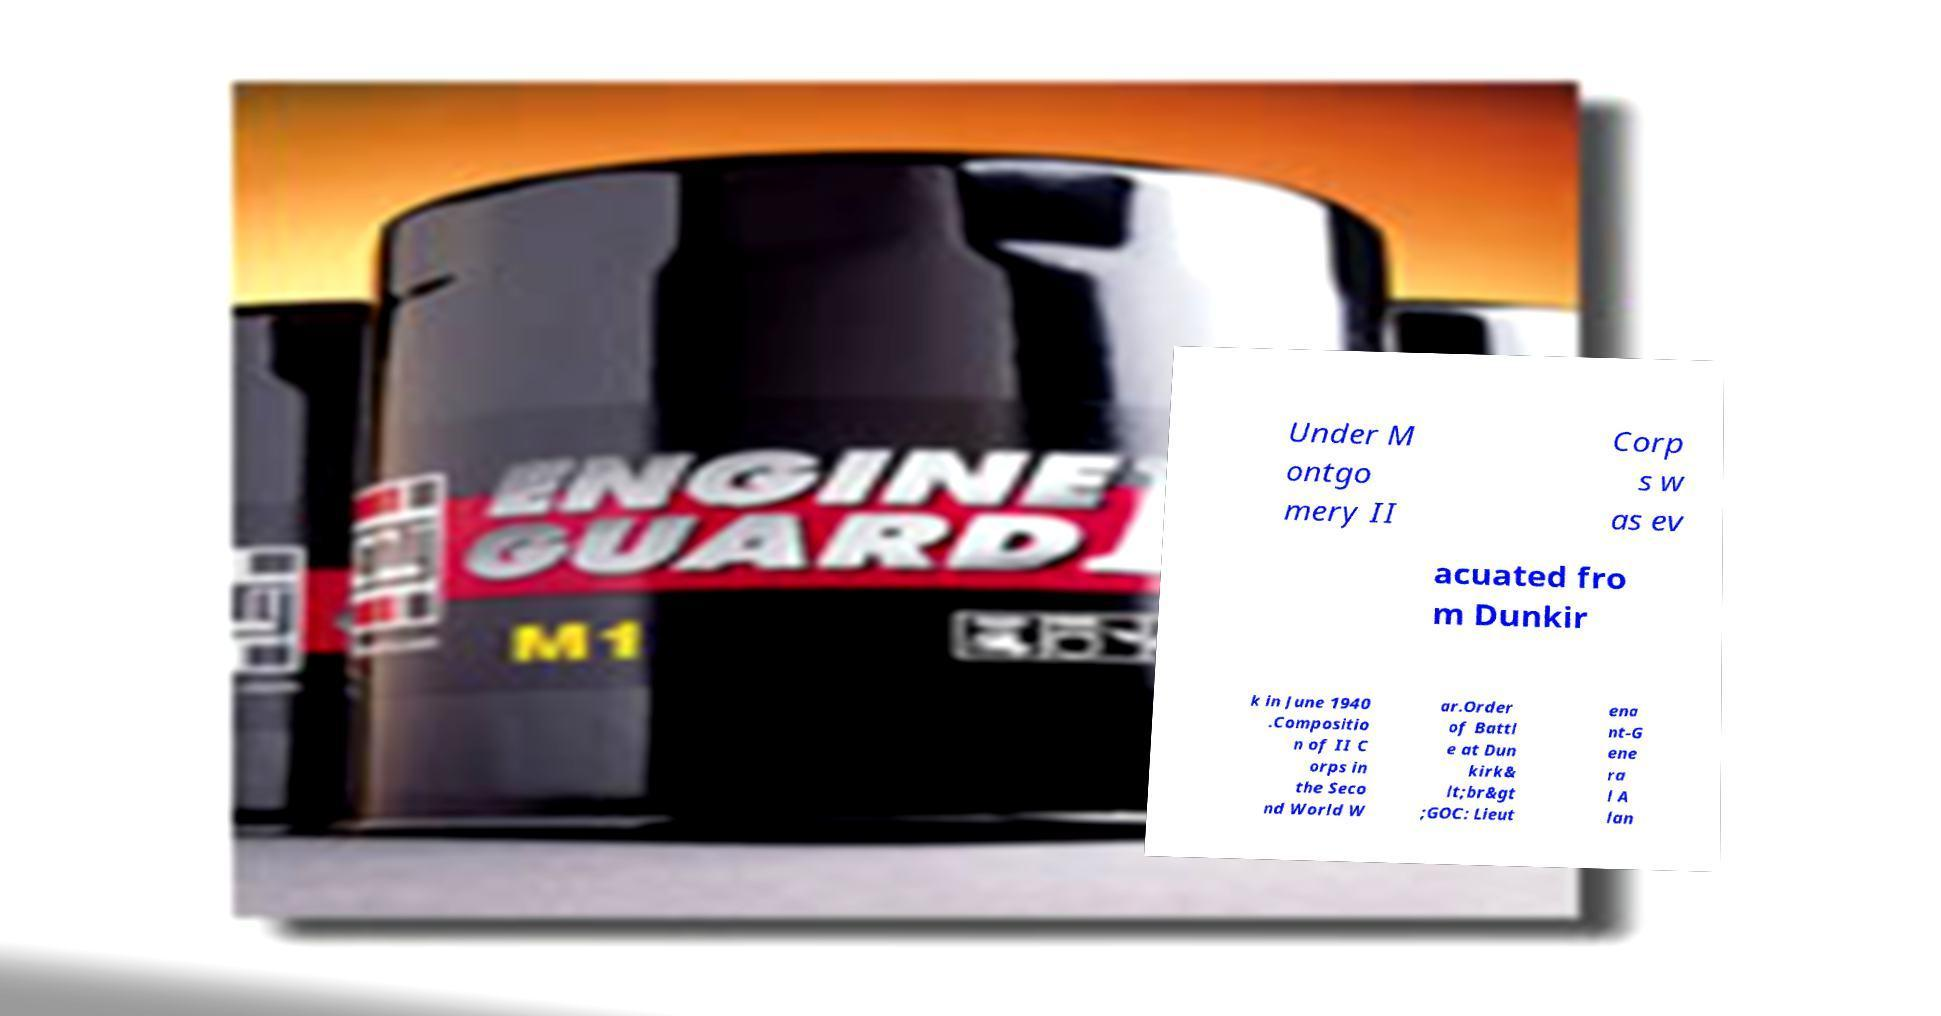What messages or text are displayed in this image? I need them in a readable, typed format. Under M ontgo mery II Corp s w as ev acuated fro m Dunkir k in June 1940 .Compositio n of II C orps in the Seco nd World W ar.Order of Battl e at Dun kirk& lt;br&gt ;GOC: Lieut ena nt-G ene ra l A lan 